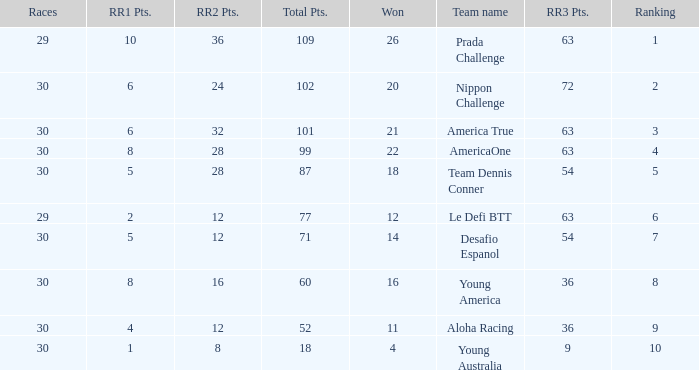Identify the rank of rr2 points when equal to 10.0. 